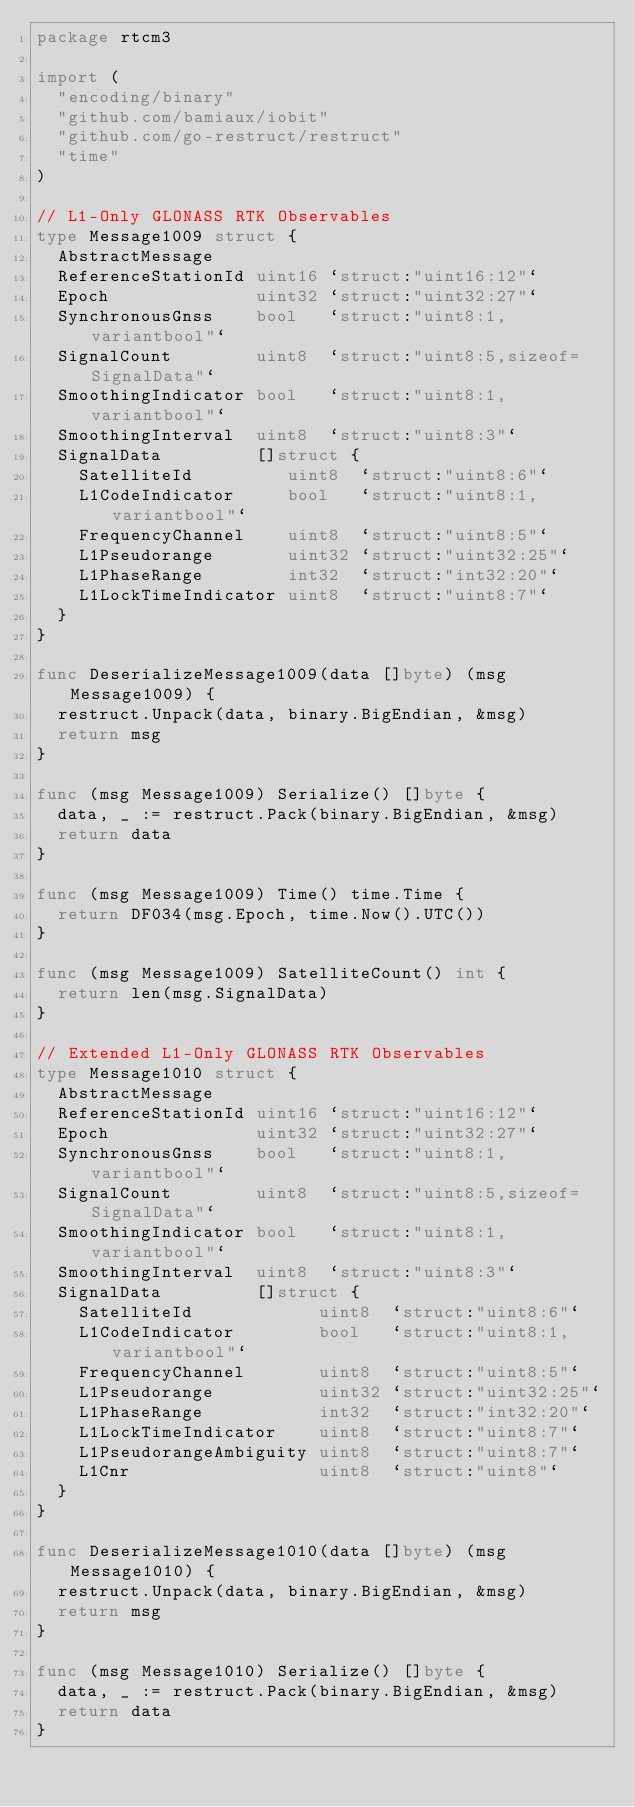<code> <loc_0><loc_0><loc_500><loc_500><_Go_>package rtcm3

import (
	"encoding/binary"
	"github.com/bamiaux/iobit"
	"github.com/go-restruct/restruct"
	"time"
)

// L1-Only GLONASS RTK Observables
type Message1009 struct {
	AbstractMessage
	ReferenceStationId uint16 `struct:"uint16:12"`
	Epoch              uint32 `struct:"uint32:27"`
	SynchronousGnss    bool   `struct:"uint8:1,variantbool"`
	SignalCount        uint8  `struct:"uint8:5,sizeof=SignalData"`
	SmoothingIndicator bool   `struct:"uint8:1,variantbool"`
	SmoothingInterval  uint8  `struct:"uint8:3"`
	SignalData         []struct {
		SatelliteId         uint8  `struct:"uint8:6"`
		L1CodeIndicator     bool   `struct:"uint8:1,variantbool"`
		FrequencyChannel    uint8  `struct:"uint8:5"`
		L1Pseudorange       uint32 `struct:"uint32:25"`
		L1PhaseRange        int32  `struct:"int32:20"`
		L1LockTimeIndicator uint8  `struct:"uint8:7"`
	}
}

func DeserializeMessage1009(data []byte) (msg Message1009) {
	restruct.Unpack(data, binary.BigEndian, &msg)
	return msg
}

func (msg Message1009) Serialize() []byte {
	data, _ := restruct.Pack(binary.BigEndian, &msg)
	return data
}

func (msg Message1009) Time() time.Time {
	return DF034(msg.Epoch, time.Now().UTC())
}

func (msg Message1009) SatelliteCount() int {
	return len(msg.SignalData)
}

// Extended L1-Only GLONASS RTK Observables
type Message1010 struct {
	AbstractMessage
	ReferenceStationId uint16 `struct:"uint16:12"`
	Epoch              uint32 `struct:"uint32:27"`
	SynchronousGnss    bool   `struct:"uint8:1,variantbool"`
	SignalCount        uint8  `struct:"uint8:5,sizeof=SignalData"`
	SmoothingIndicator bool   `struct:"uint8:1,variantbool"`
	SmoothingInterval  uint8  `struct:"uint8:3"`
	SignalData         []struct {
		SatelliteId            uint8  `struct:"uint8:6"`
		L1CodeIndicator        bool   `struct:"uint8:1,variantbool"`
		FrequencyChannel       uint8  `struct:"uint8:5"`
		L1Pseudorange          uint32 `struct:"uint32:25"`
		L1PhaseRange           int32  `struct:"int32:20"`
		L1LockTimeIndicator    uint8  `struct:"uint8:7"`
		L1PseudorangeAmbiguity uint8  `struct:"uint8:7"`
		L1Cnr                  uint8  `struct:"uint8"`
	}
}

func DeserializeMessage1010(data []byte) (msg Message1010) {
	restruct.Unpack(data, binary.BigEndian, &msg)
	return msg
}

func (msg Message1010) Serialize() []byte {
	data, _ := restruct.Pack(binary.BigEndian, &msg)
	return data
}
</code> 